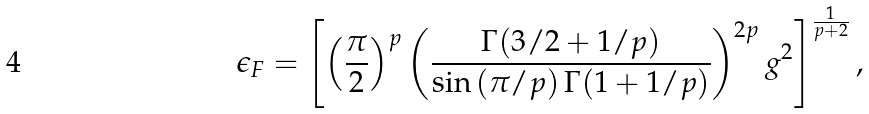<formula> <loc_0><loc_0><loc_500><loc_500>\epsilon _ { F } = \left [ \left ( \frac { \pi } { 2 } \right ) ^ { p } \left ( \frac { \Gamma ( 3 / 2 + 1 / p ) } { \sin \left ( \pi / p \right ) \Gamma ( 1 + 1 / p ) } \right ) ^ { 2 p } g ^ { 2 } \right ] ^ { \frac { 1 } { p + 2 } } ,</formula> 